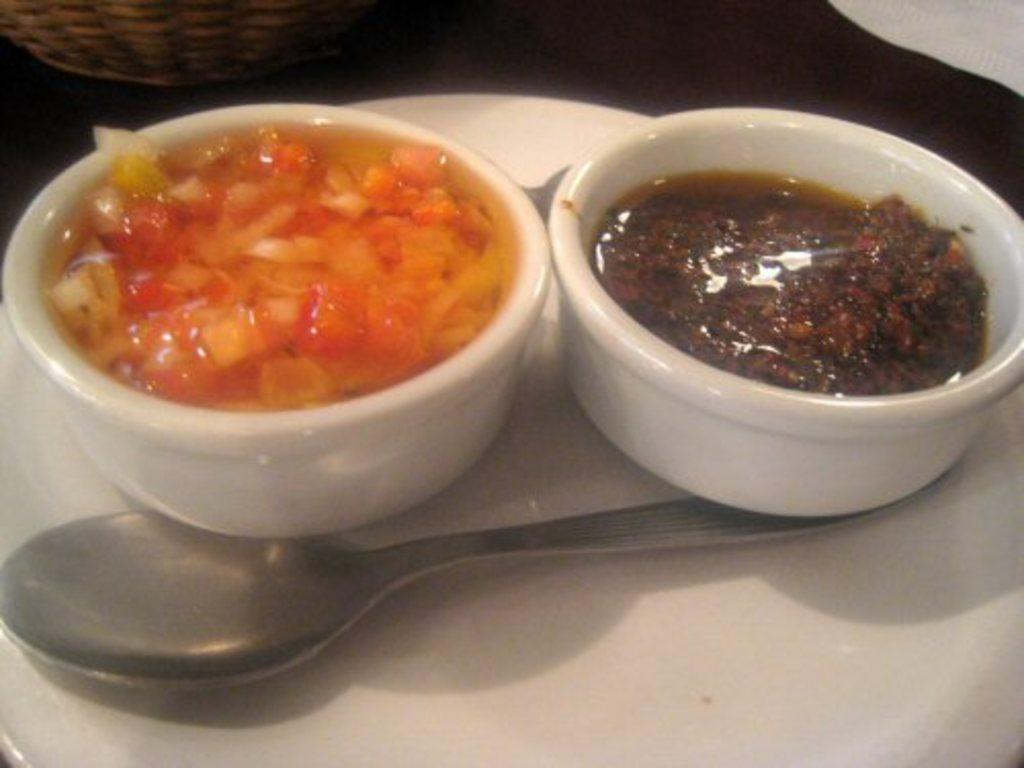What utensil is visible in the image? There is a spoon in the image. What is contained in the bowl in the image? There are food items in a bowl in the image. What is another dish-like object present in the image? There is a plate in the image. What type of calculator is being used to measure the food items in the image? There is no calculator present in the image. Can you describe the wave pattern visible in the food items? There is no wave pattern visible in the food items; they are contained in a bowl. 